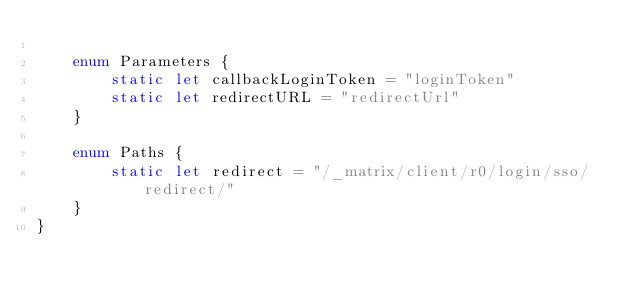<code> <loc_0><loc_0><loc_500><loc_500><_Swift_>    
    enum Parameters {
        static let callbackLoginToken = "loginToken"
        static let redirectURL = "redirectUrl"
    }
    
    enum Paths {
        static let redirect = "/_matrix/client/r0/login/sso/redirect/"
    }
}
</code> 